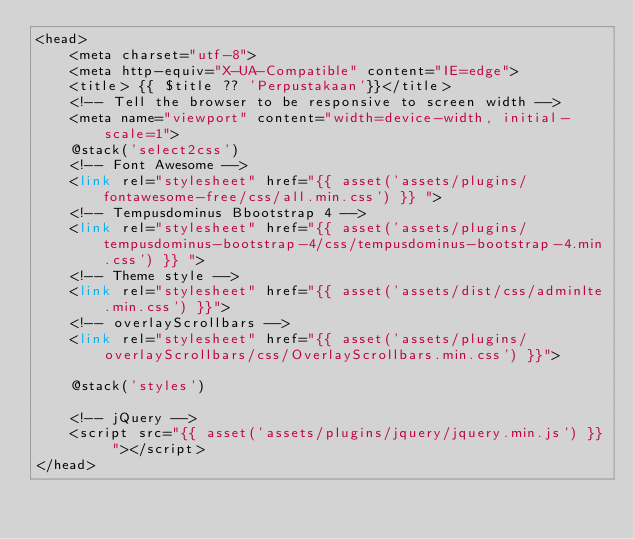<code> <loc_0><loc_0><loc_500><loc_500><_PHP_><head>
    <meta charset="utf-8">
    <meta http-equiv="X-UA-Compatible" content="IE=edge">
    <title> {{ $title ?? 'Perpustakaan'}}</title>
    <!-- Tell the browser to be responsive to screen width -->
    <meta name="viewport" content="width=device-width, initial-scale=1">
    @stack('select2css')
    <!-- Font Awesome -->
    <link rel="stylesheet" href="{{ asset('assets/plugins/fontawesome-free/css/all.min.css') }} ">
    <!-- Tempusdominus Bbootstrap 4 -->
    <link rel="stylesheet" href="{{ asset('assets/plugins/tempusdominus-bootstrap-4/css/tempusdominus-bootstrap-4.min.css') }} ">
    <!-- Theme style -->
    <link rel="stylesheet" href="{{ asset('assets/dist/css/adminlte.min.css') }}">
    <!-- overlayScrollbars -->
    <link rel="stylesheet" href="{{ asset('assets/plugins/overlayScrollbars/css/OverlayScrollbars.min.css') }}">

    @stack('styles')

    <!-- jQuery -->
    <script src="{{ asset('assets/plugins/jquery/jquery.min.js') }} "></script>
</head>
</code> 